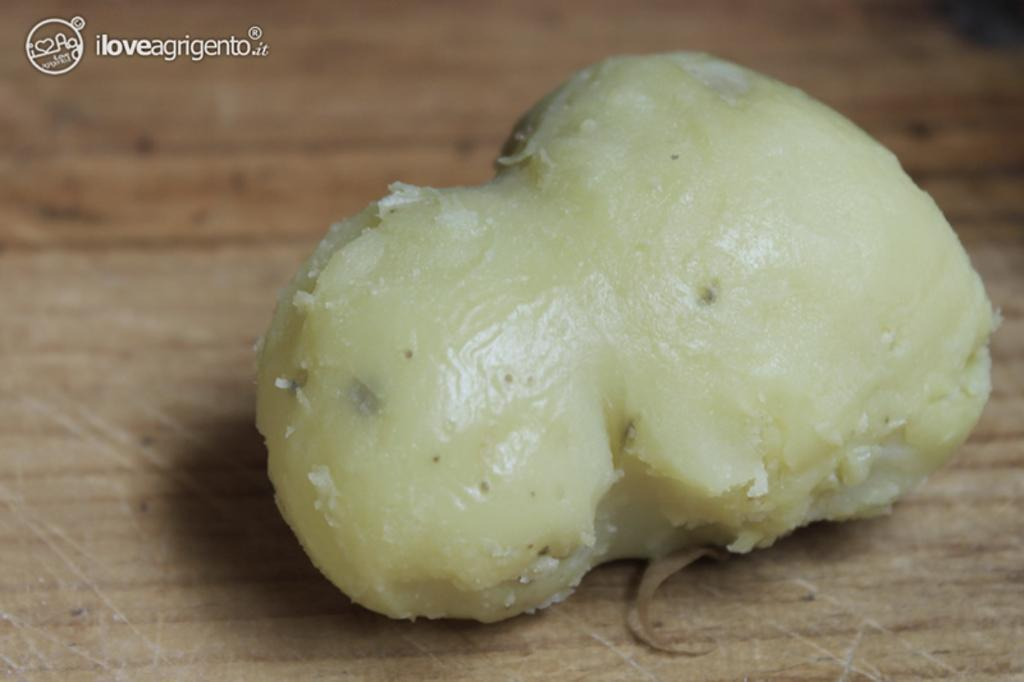What type of food item is present in the image? There is a vegetable in the image. What is the color of the vegetable? The vegetable is in cream color. What is the vegetable placed on in the image? The vegetable is on a brown color surface. What type of song can be heard playing in the background of the image? There is no song or audio present in the image, as it is a still image. Can you see a lake in the image? There is no lake visible in the image. Is there any indication of a holiday in the image? There is no indication of a holiday in the image. 